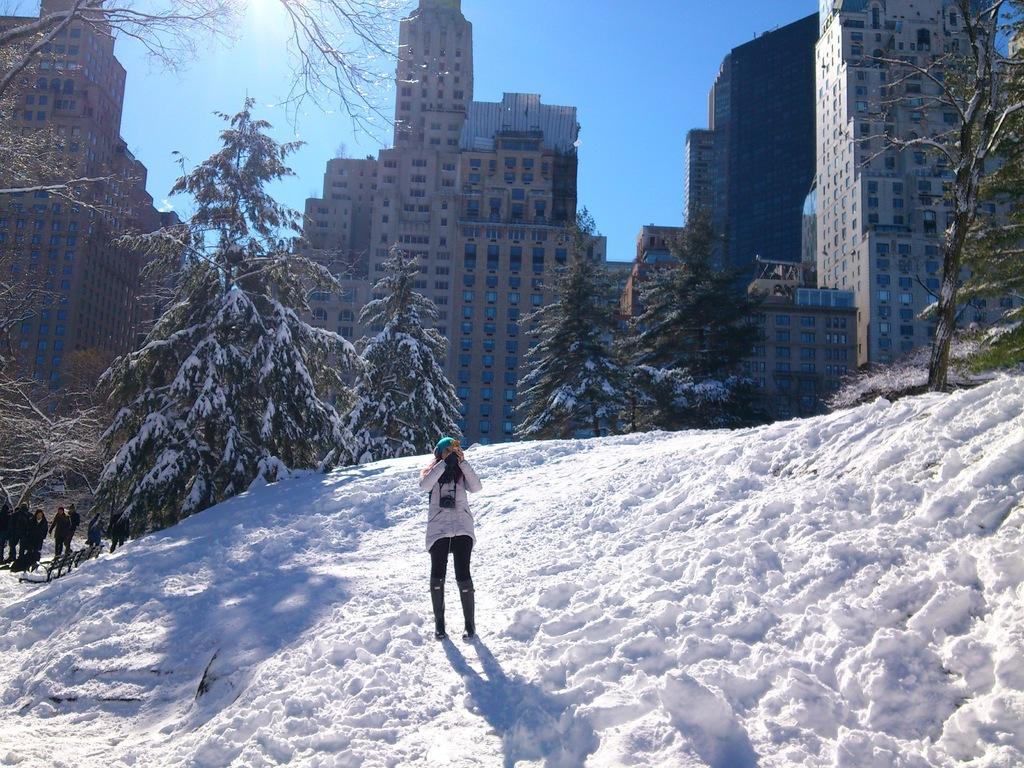Could you give a brief overview of what you see in this image? In the foreground of the picture there is a woman standing in snow. In the center of the picture there are trees and people. In the background there are buildings. Sky is sunny. 